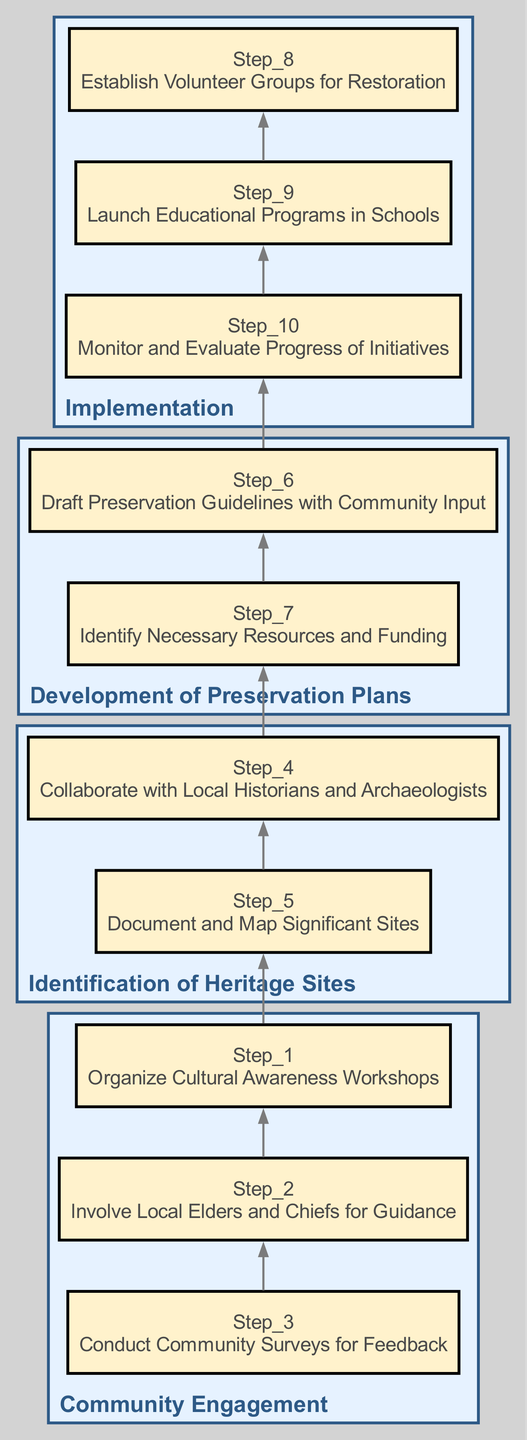What is the first step in community engagement? The diagram indicates that the first step in community engagement is to "Organize Cultural Awareness Workshops" which is listed under the category of "Community Engagement".
Answer: Organize Cultural Awareness Workshops How many steps are there in the implementation phase? When examining the "Implementation" category, it shows three distinct steps: "Establish Volunteer Groups for Restoration", "Launch Educational Programs in Schools", and "Monitor and Evaluate Progress of Initiatives". Thus, the total is three steps.
Answer: 3 Which step follows the documentation and mapping of significant sites? The step that follows "Document and Map Significant Sites", which is the fifth step in the "Identification of Heritage Sites" category, is "Draft Preservation Guidelines with Community Input", which is the sixth step in the subsequent category.
Answer: Draft Preservation Guidelines with Community Input What category includes the step involving local elders and chiefs? Upon looking at the steps in the diagram, "Involve Local Elders and Chiefs for Guidance" falls under the "Community Engagement" category, indicating it is the second step of this category.
Answer: Community Engagement How many nodes are associated with developing preservation plans? The category titled "Development of Preservation Plans" includes two nodes: "Draft Preservation Guidelines with Community Input" and "Identify Necessary Resources and Funding". Thus, the total is two nodes.
Answer: 2 Which phase comes directly after community engagement? After "Community Engagement", the next phase, as shown in the diagram, is "Identification of Heritage Sites", which indicates the flow of the process.
Answer: Identification of Heritage Sites What is the final node of the diagram? The last node in the flow, as per the bottom-up structure established in the diagram, is "Monitor and Evaluate Progress of Initiatives", marking the completion of the implementation phase.
Answer: Monitor and Evaluate Progress of Initiatives What is the primary purpose of the "Conduct Community Surveys for Feedback" step? This step, which is the third within the "Community Engagement" category, aims to gather insights and opinions from the community regarding cultural heritage preservation, facilitating a more inclusive approach to further initiatives.
Answer: Gather insights and opinions How does the chart indicate the relationship between the identification of heritage sites and the development of preservation plans? The flow from "Identification of Heritage Sites" to "Development of Preservation Plans" illustrates a sequential relationship where identifying sites is necessary before creating plans to preserve them, indicating a logical progression from awareness to action.
Answer: Sequential relationship 